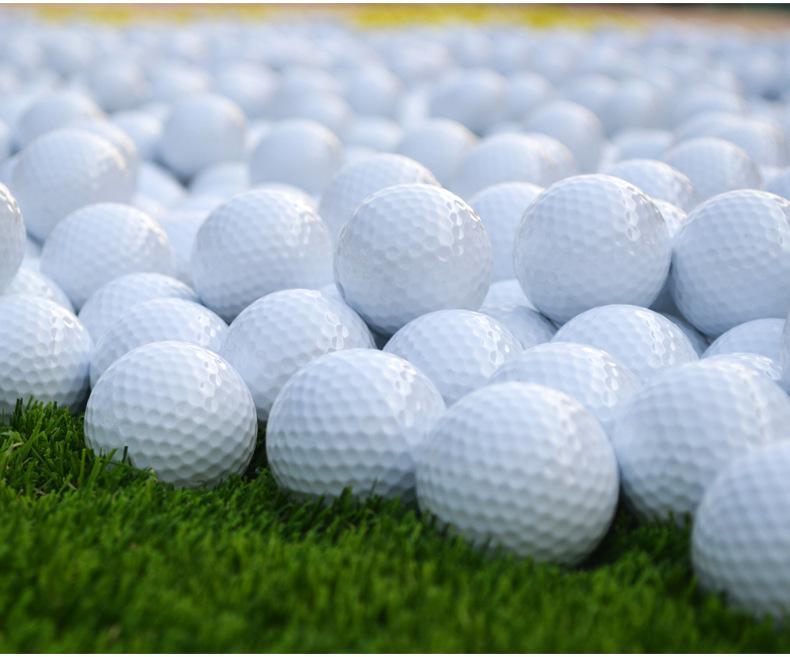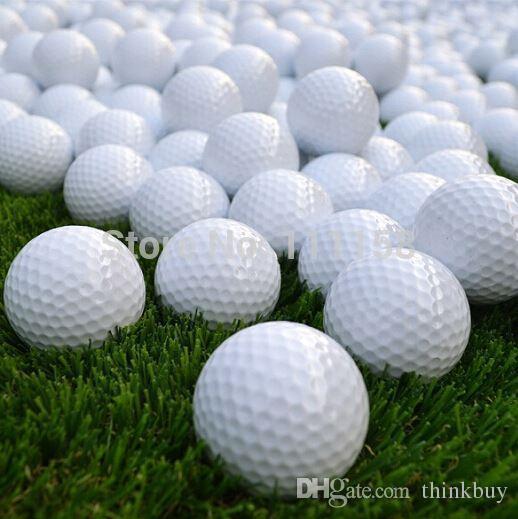The first image is the image on the left, the second image is the image on the right. For the images shown, is this caption "All golf balls shown are plain and unmarked." true? Answer yes or no. Yes. 